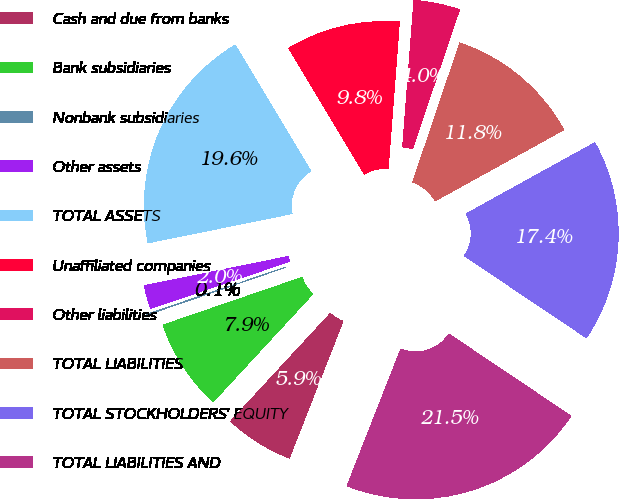<chart> <loc_0><loc_0><loc_500><loc_500><pie_chart><fcel>Cash and due from banks<fcel>Bank subsidiaries<fcel>Nonbank subsidiaries<fcel>Other assets<fcel>TOTAL ASSETS<fcel>Unaffiliated companies<fcel>Other liabilities<fcel>TOTAL LIABILITIES<fcel>TOTAL STOCKHOLDERS' EQUITY<fcel>TOTAL LIABILITIES AND<nl><fcel>5.92%<fcel>7.87%<fcel>0.06%<fcel>2.01%<fcel>19.59%<fcel>9.82%<fcel>3.97%<fcel>11.78%<fcel>17.45%<fcel>21.54%<nl></chart> 